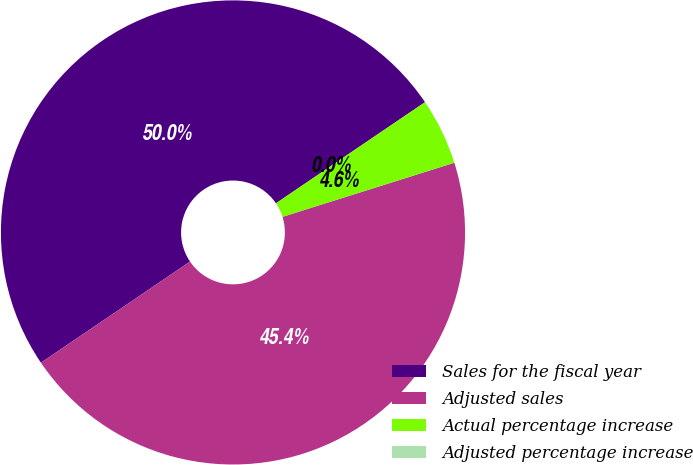Convert chart. <chart><loc_0><loc_0><loc_500><loc_500><pie_chart><fcel>Sales for the fiscal year<fcel>Adjusted sales<fcel>Actual percentage increase<fcel>Adjusted percentage increase<nl><fcel>50.0%<fcel>45.37%<fcel>4.63%<fcel>0.0%<nl></chart> 